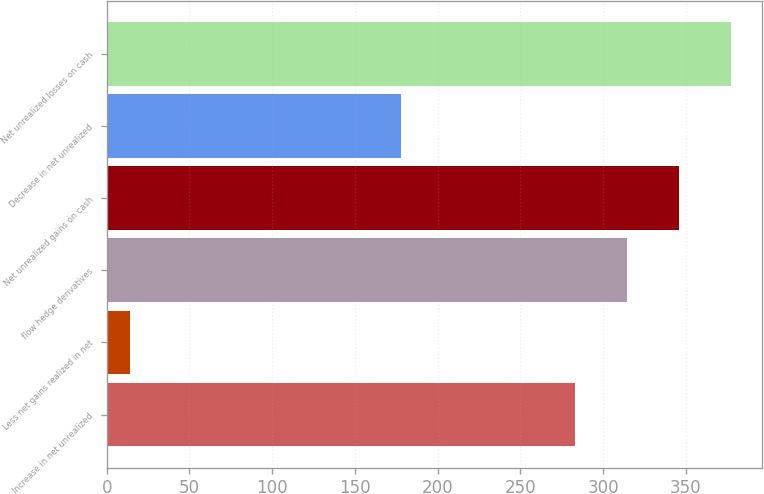Convert chart. <chart><loc_0><loc_0><loc_500><loc_500><bar_chart><fcel>Increase in net unrealized<fcel>Less net gains realized in net<fcel>flow hedge derivatives<fcel>Net unrealized gains on cash<fcel>Decrease in net unrealized<fcel>Net unrealized losses on cash<nl><fcel>283<fcel>14<fcel>314.5<fcel>346<fcel>178<fcel>377.5<nl></chart> 